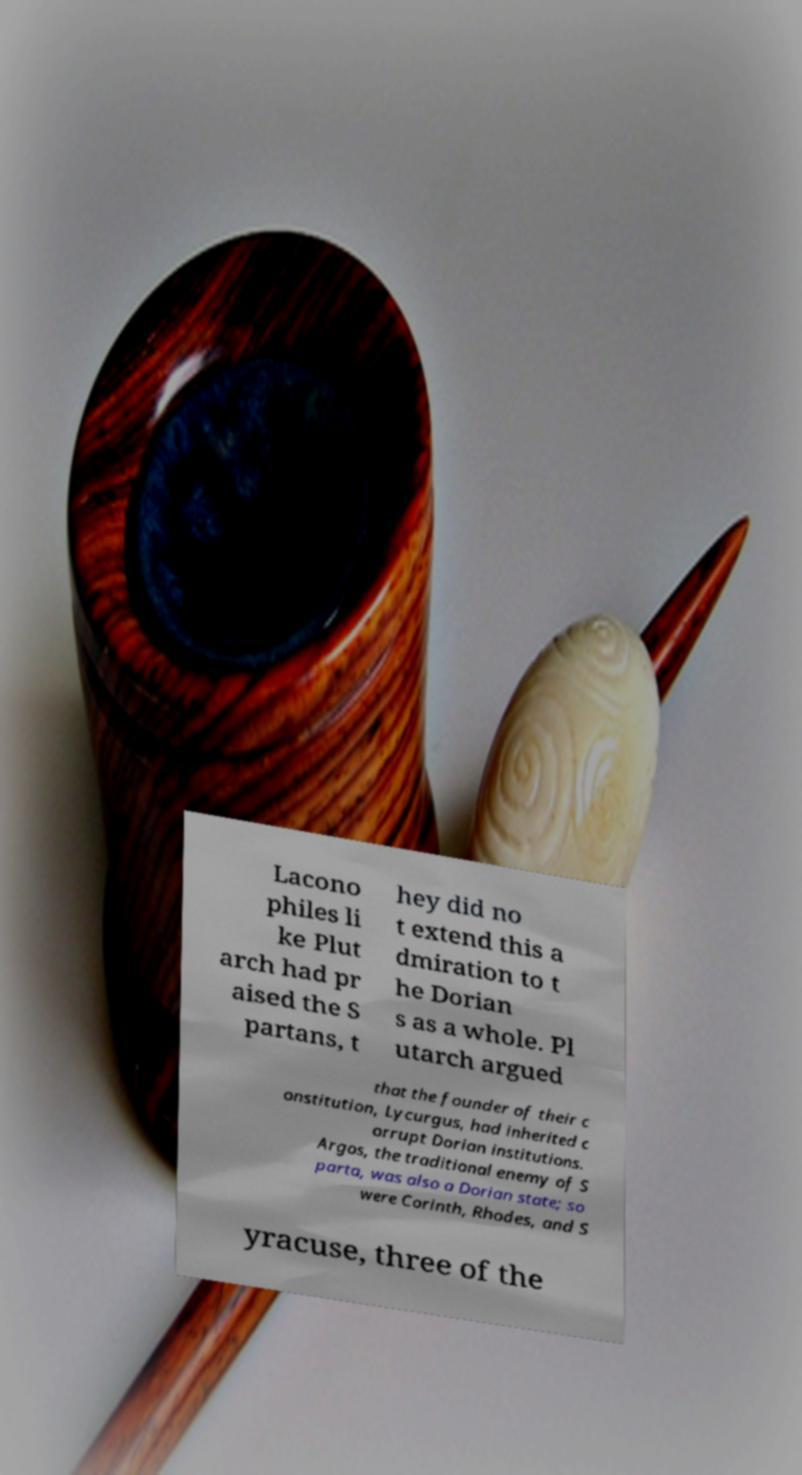Could you extract and type out the text from this image? Lacono philes li ke Plut arch had pr aised the S partans, t hey did no t extend this a dmiration to t he Dorian s as a whole. Pl utarch argued that the founder of their c onstitution, Lycurgus, had inherited c orrupt Dorian institutions. Argos, the traditional enemy of S parta, was also a Dorian state; so were Corinth, Rhodes, and S yracuse, three of the 